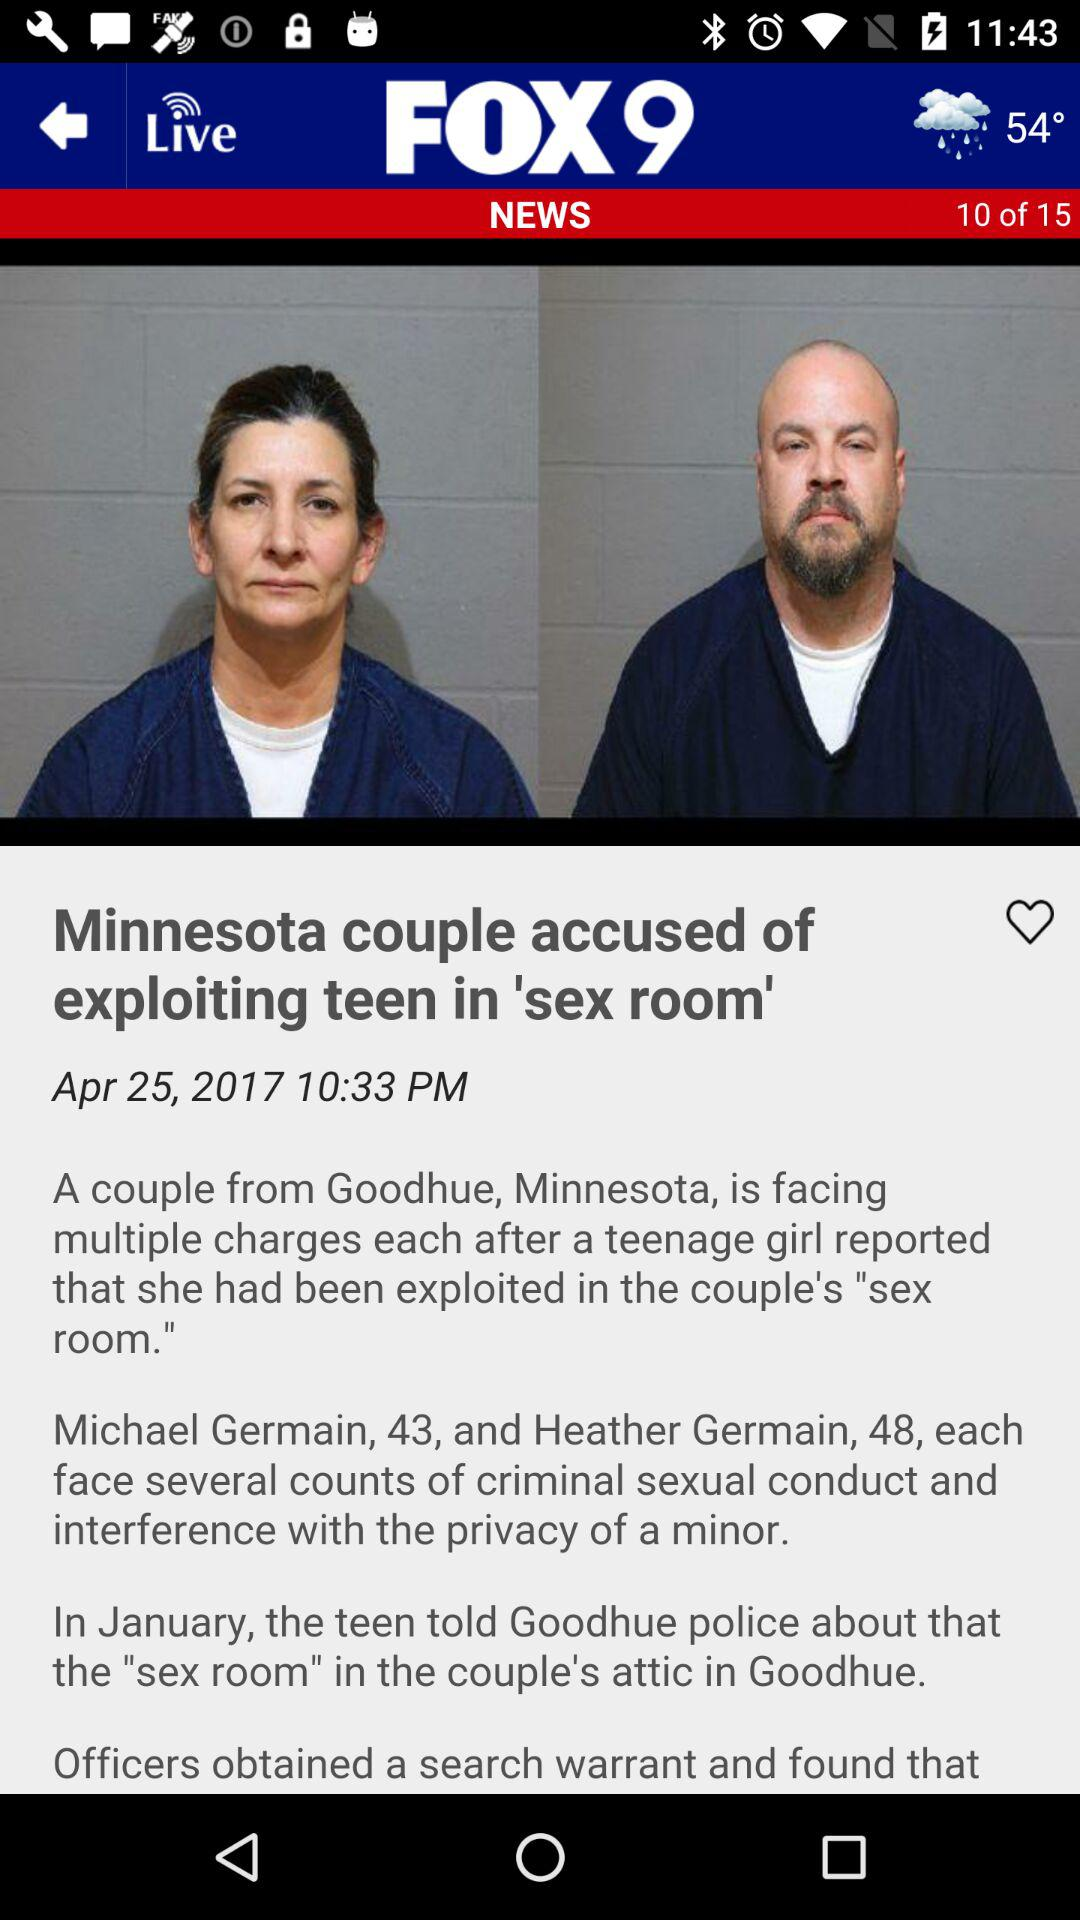What is the name of the application? The name of the application is "FOX 9". 